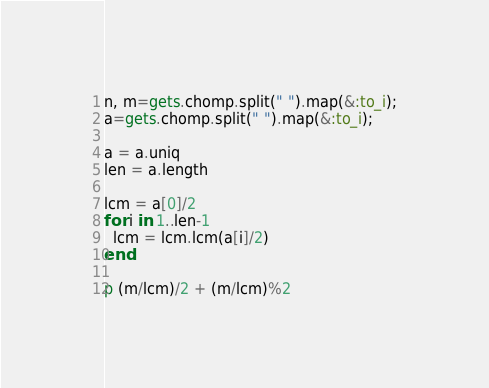Convert code to text. <code><loc_0><loc_0><loc_500><loc_500><_Ruby_>n, m=gets.chomp.split(" ").map(&:to_i);
a=gets.chomp.split(" ").map(&:to_i);

a = a.uniq
len = a.length

lcm = a[0]/2
for i in 1..len-1
  lcm = lcm.lcm(a[i]/2)
end

p (m/lcm)/2 + (m/lcm)%2</code> 